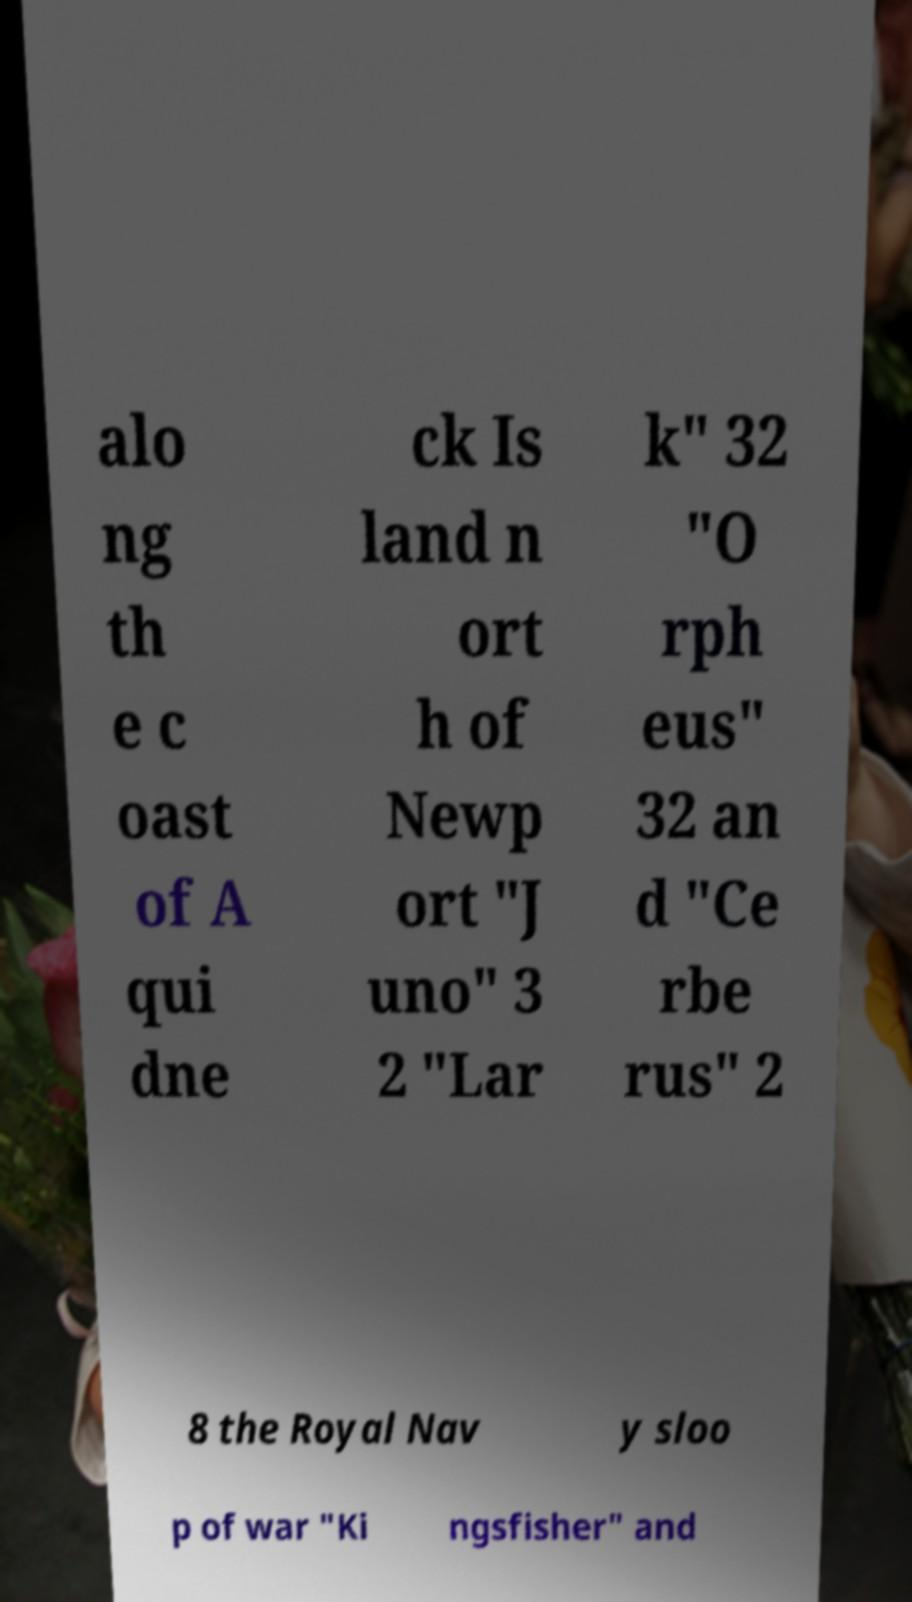For documentation purposes, I need the text within this image transcribed. Could you provide that? alo ng th e c oast of A qui dne ck Is land n ort h of Newp ort "J uno" 3 2 "Lar k" 32 "O rph eus" 32 an d "Ce rbe rus" 2 8 the Royal Nav y sloo p of war "Ki ngsfisher" and 